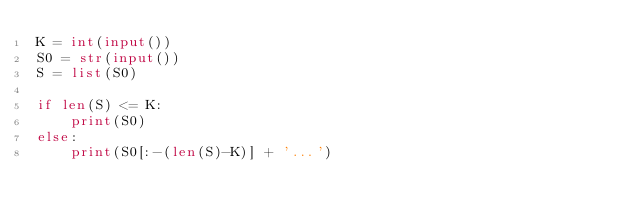Convert code to text. <code><loc_0><loc_0><loc_500><loc_500><_Python_>K = int(input())
S0 = str(input())
S = list(S0)

if len(S) <= K:
    print(S0)
else:
    print(S0[:-(len(S)-K)] + '...')</code> 